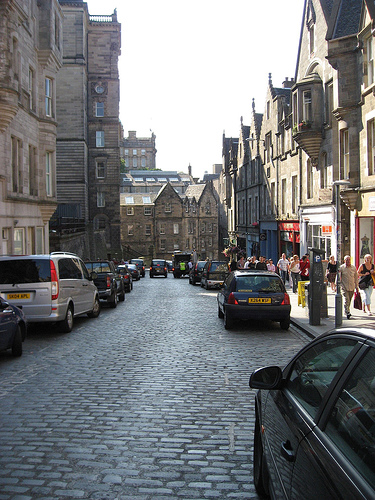<image>
Is there a car to the left of the car? Yes. From this viewpoint, the car is positioned to the left side relative to the car. 